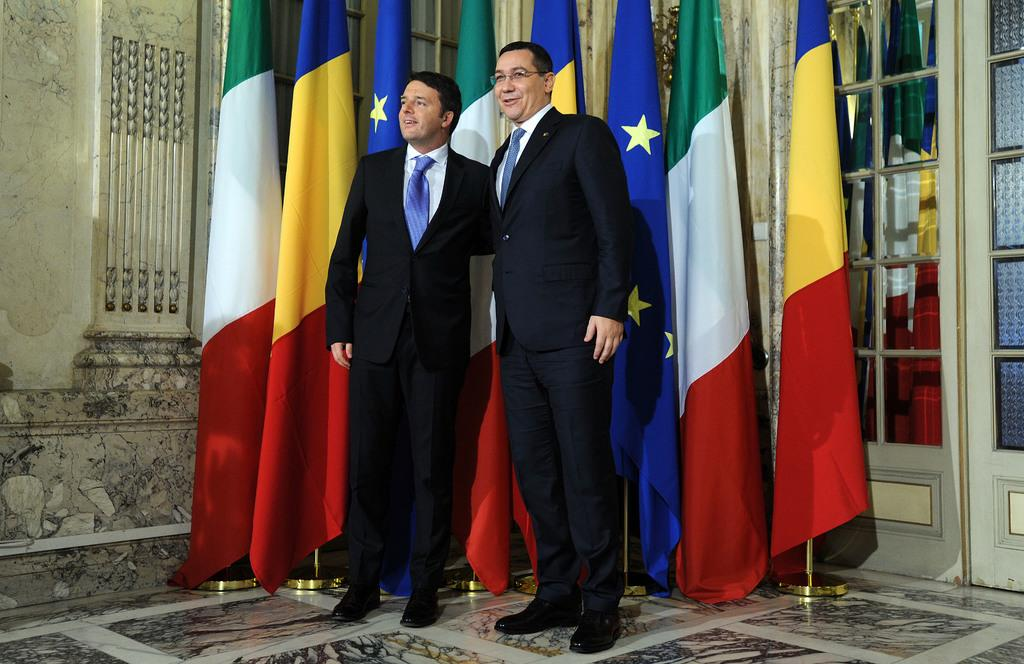What are the men in the image doing? The men in the image are standing and smiling. Where are the men located in the image? The men are standing on the floor. What can be seen in the background of the image? There are flags, a door with mirrors, and a wall in the background of the image. How are the flags positioned in the image? The flags are attached to flag posts. What type of pen is the man holding in the image? There is no pen present in the image; the men are not holding any objects. 